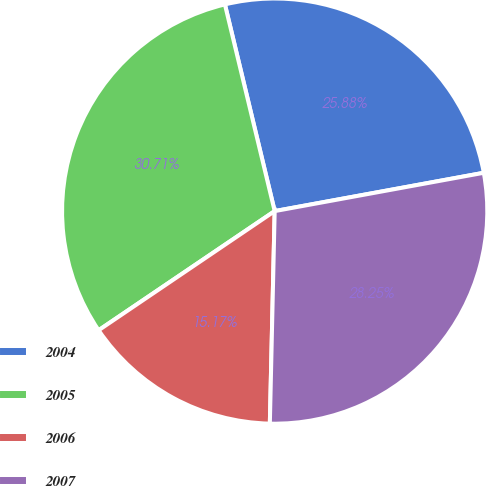<chart> <loc_0><loc_0><loc_500><loc_500><pie_chart><fcel>2004<fcel>2005<fcel>2006<fcel>2007<nl><fcel>25.88%<fcel>30.71%<fcel>15.17%<fcel>28.25%<nl></chart> 